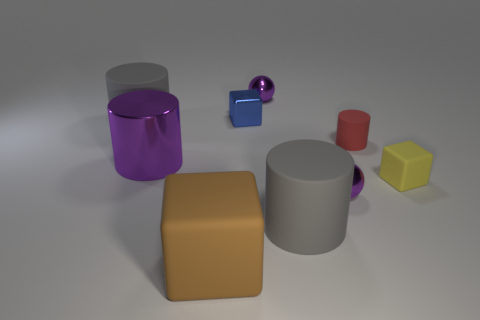Can you describe the texture of the objects and how light interacts with their surfaces? The objects exhibit both matte and reflective surfaces. The matte objects diffuse the light, giving them a soft appearance, while the reflective ones, like the small blue sphere, create highlights and mirror their surroundings, demonstrating a smooth and shiny texture. 